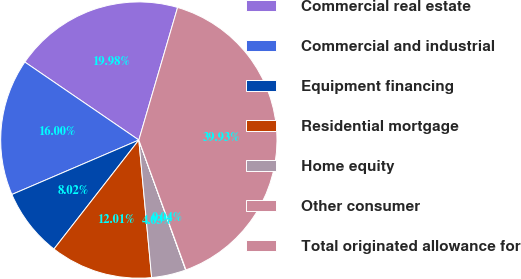<chart> <loc_0><loc_0><loc_500><loc_500><pie_chart><fcel>Commercial real estate<fcel>Commercial and industrial<fcel>Equipment financing<fcel>Residential mortgage<fcel>Home equity<fcel>Other consumer<fcel>Total originated allowance for<nl><fcel>19.98%<fcel>16.0%<fcel>8.02%<fcel>12.01%<fcel>4.03%<fcel>0.04%<fcel>39.93%<nl></chart> 